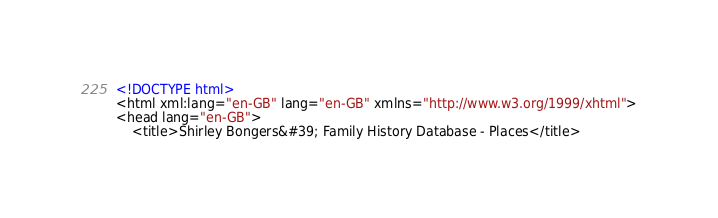<code> <loc_0><loc_0><loc_500><loc_500><_HTML_><!DOCTYPE html>
<html xml:lang="en-GB" lang="en-GB" xmlns="http://www.w3.org/1999/xhtml">
<head lang="en-GB">
	<title>Shirley Bongers&#39; Family History Database - Places</title></code> 